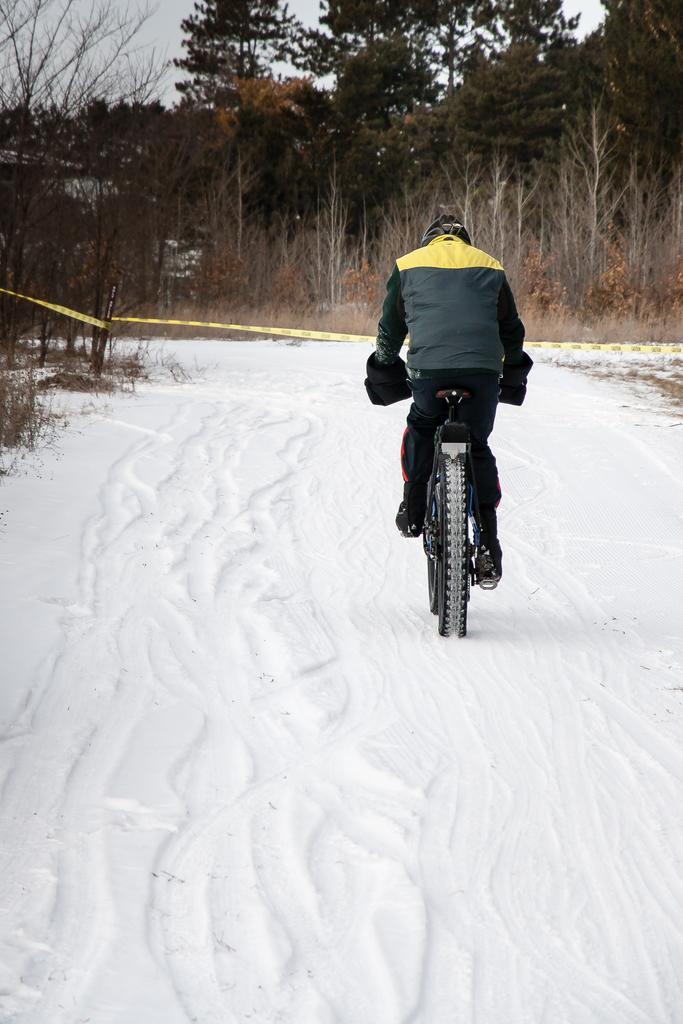Please provide a concise description of this image. In this image, we can see snow on the ground, there is a person riding a bicycle, there are some trees and at the top there is a sky. 